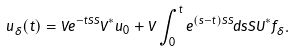Convert formula to latex. <formula><loc_0><loc_0><loc_500><loc_500>u _ { \delta } ( t ) = V e ^ { - t \bar { S } S } V ^ { * } u _ { 0 } + V \int _ { 0 } ^ { t } e ^ { ( s - t ) \bar { S } S } d s \bar { S } U ^ { * } f _ { \delta } .</formula> 